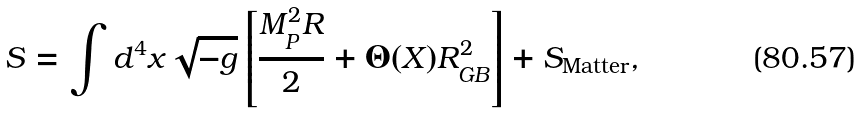<formula> <loc_0><loc_0><loc_500><loc_500>S = \int d ^ { 4 } x \sqrt { - g } \left [ \frac { M _ { P } ^ { 2 } R } { 2 } + \Theta ( X ) R _ { G B } ^ { 2 } \right ] + S _ { \text {Matter} } ,</formula> 